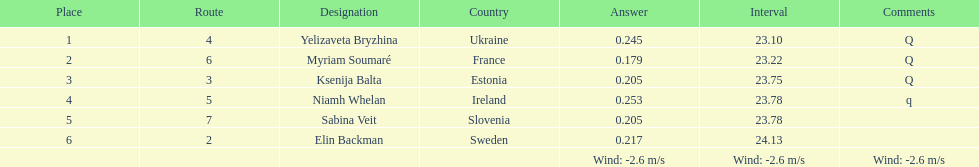Do any of the lanes follow a consecutive sequence? No. Would you mind parsing the complete table? {'header': ['Place', 'Route', 'Designation', 'Country', 'Answer', 'Interval', 'Comments'], 'rows': [['1', '4', 'Yelizaveta Bryzhina', 'Ukraine', '0.245', '23.10', 'Q'], ['2', '6', 'Myriam Soumaré', 'France', '0.179', '23.22', 'Q'], ['3', '3', 'Ksenija Balta', 'Estonia', '0.205', '23.75', 'Q'], ['4', '5', 'Niamh Whelan', 'Ireland', '0.253', '23.78', 'q'], ['5', '7', 'Sabina Veit', 'Slovenia', '0.205', '23.78', ''], ['6', '2', 'Elin Backman', 'Sweden', '0.217', '24.13', ''], ['', '', '', '', 'Wind: -2.6\xa0m/s', 'Wind: -2.6\xa0m/s', 'Wind: -2.6\xa0m/s']]} 